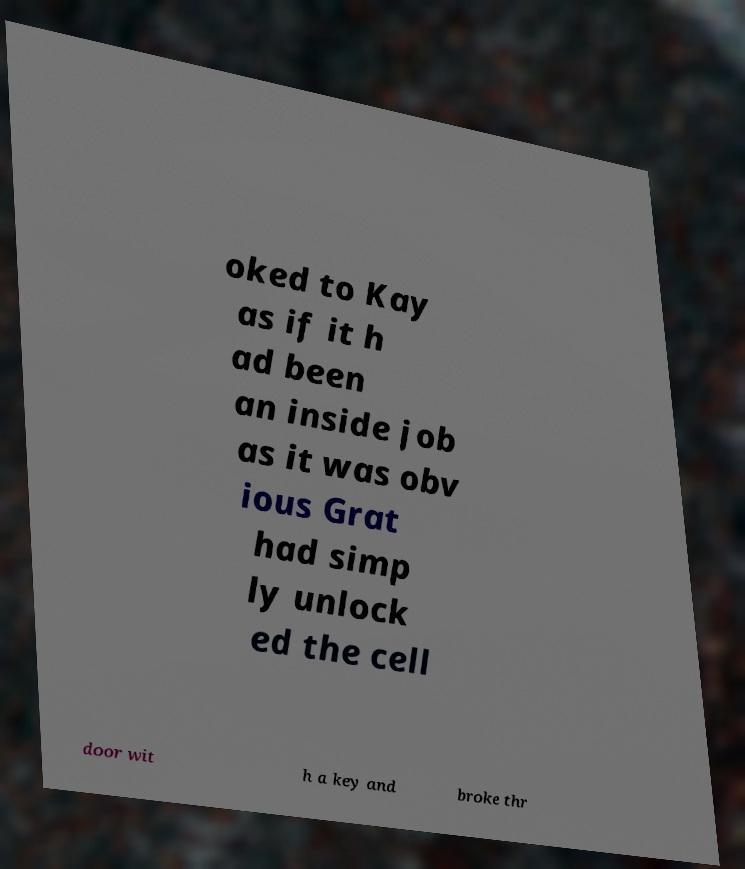Could you assist in decoding the text presented in this image and type it out clearly? oked to Kay as if it h ad been an inside job as it was obv ious Grat had simp ly unlock ed the cell door wit h a key and broke thr 